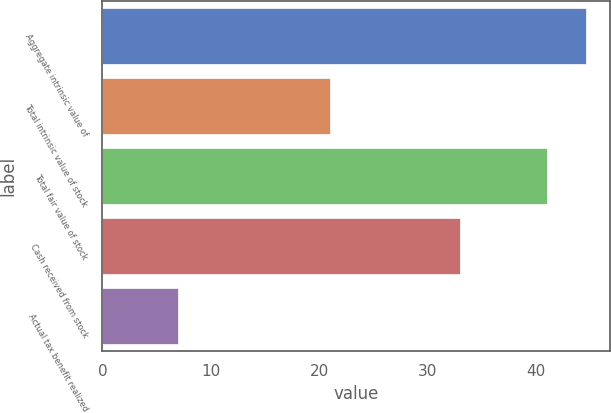Convert chart. <chart><loc_0><loc_0><loc_500><loc_500><bar_chart><fcel>Aggregate intrinsic value of<fcel>Total intrinsic value of stock<fcel>Total fair value of stock<fcel>Cash received from stock<fcel>Actual tax benefit realized<nl><fcel>44.6<fcel>21<fcel>41<fcel>33<fcel>7<nl></chart> 